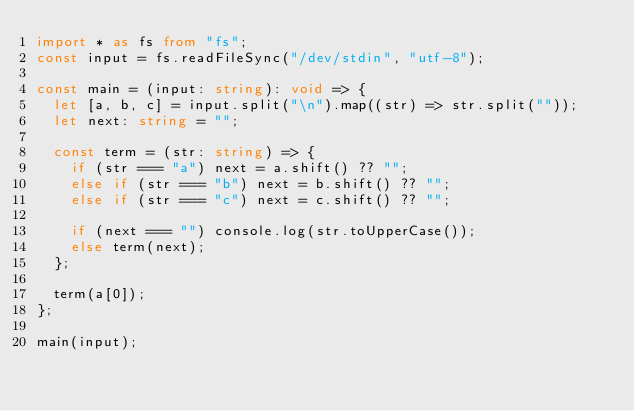Convert code to text. <code><loc_0><loc_0><loc_500><loc_500><_TypeScript_>import * as fs from "fs";
const input = fs.readFileSync("/dev/stdin", "utf-8");

const main = (input: string): void => {
  let [a, b, c] = input.split("\n").map((str) => str.split(""));
  let next: string = "";

  const term = (str: string) => {
    if (str === "a") next = a.shift() ?? "";
    else if (str === "b") next = b.shift() ?? "";
    else if (str === "c") next = c.shift() ?? "";

    if (next === "") console.log(str.toUpperCase());
    else term(next);
  };

  term(a[0]);
};

main(input);
</code> 